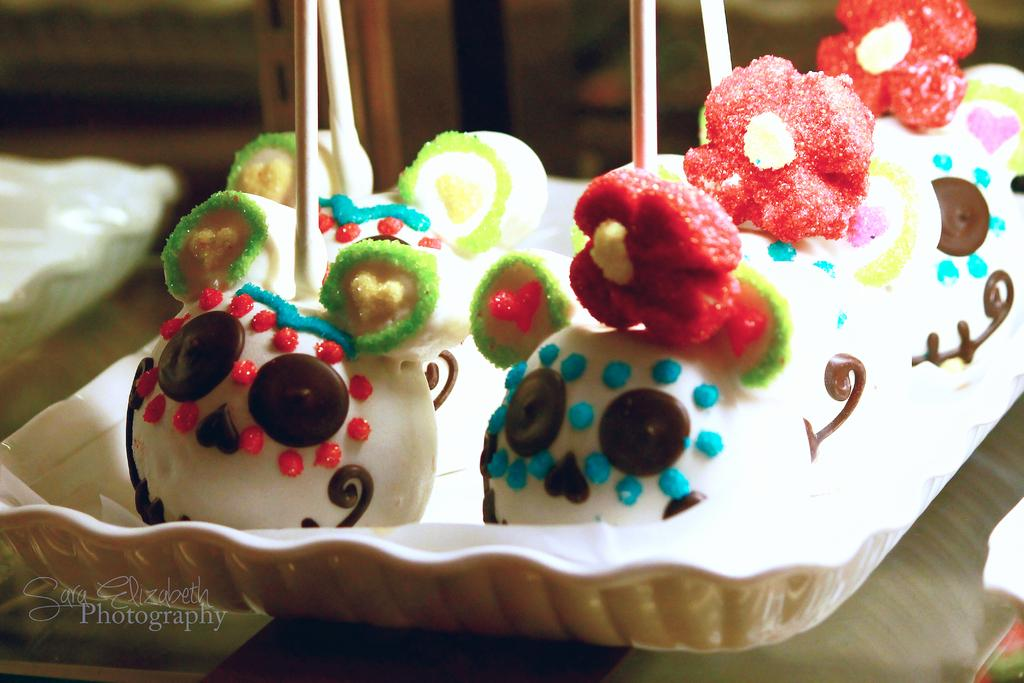What is on the tray that is visible in the image? There is a food item on a tray in the image. Can you describe the other tray that is visible in the image? There is another tray on a table in the image. What type of station is depicted on the tray? There is no station depicted on the tray; it contains a food item. What are the names of the trucks that are delivering the food item? There is no reference to trucks or their names in the image; it only shows a food item on a tray and another tray on a table. 